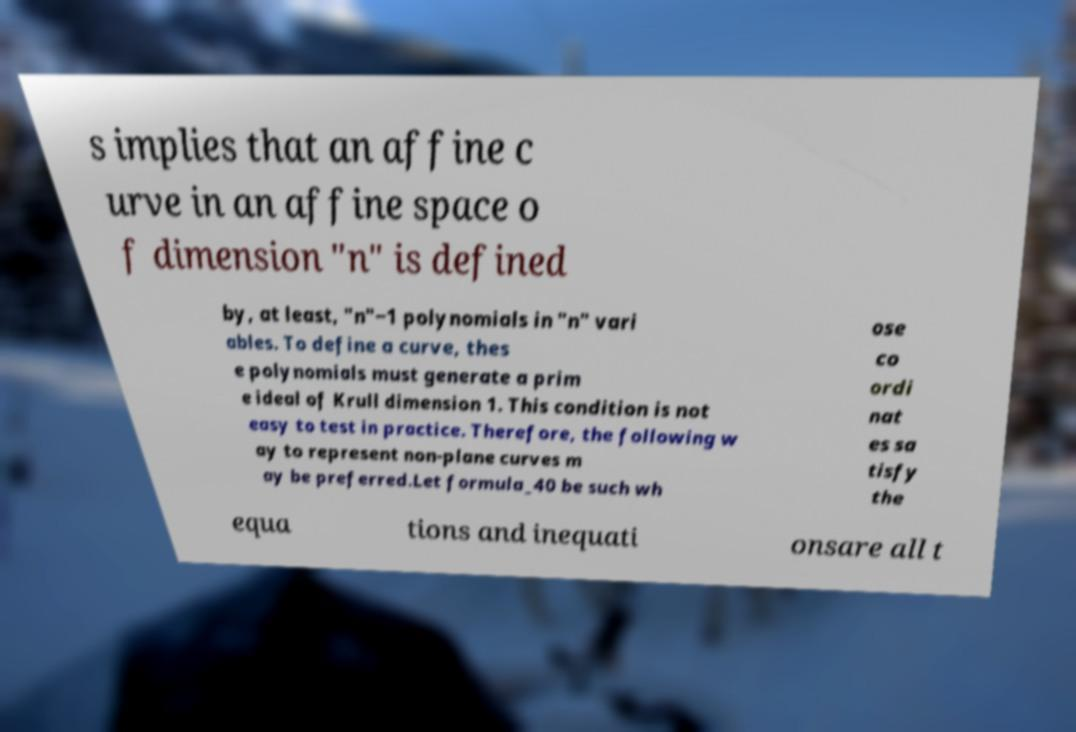What messages or text are displayed in this image? I need them in a readable, typed format. s implies that an affine c urve in an affine space o f dimension "n" is defined by, at least, "n"−1 polynomials in "n" vari ables. To define a curve, thes e polynomials must generate a prim e ideal of Krull dimension 1. This condition is not easy to test in practice. Therefore, the following w ay to represent non-plane curves m ay be preferred.Let formula_40 be such wh ose co ordi nat es sa tisfy the equa tions and inequati onsare all t 